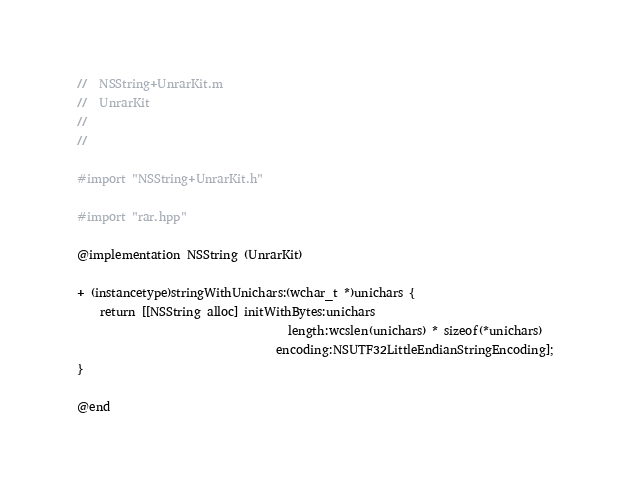Convert code to text. <code><loc_0><loc_0><loc_500><loc_500><_ObjectiveC_>//  NSString+UnrarKit.m
//  UnrarKit
//
//

#import "NSString+UnrarKit.h"

#import "rar.hpp"

@implementation NSString (UnrarKit)

+ (instancetype)stringWithUnichars:(wchar_t *)unichars {
    return [[NSString alloc] initWithBytes:unichars
                                    length:wcslen(unichars) * sizeof(*unichars)
                                  encoding:NSUTF32LittleEndianStringEncoding];
}

@end
</code> 